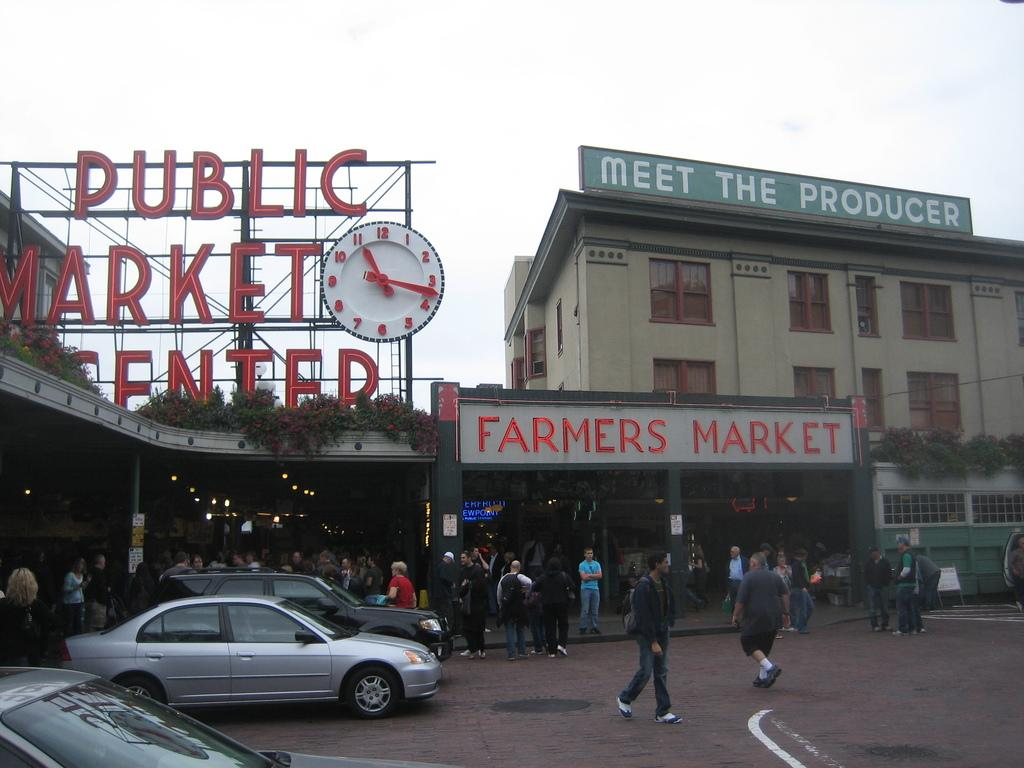How many people can be seen in the image? There are many people in the image. What else is present in the image besides people? There are vehicles on the road and a clock in the image. What is the condition of the sky in the image? The sky is bright in the image. What type of quince is being sold in the image? There is no quince present in the image. How many crates of corn can be seen in the image? There is no corn or crate present in the image. 